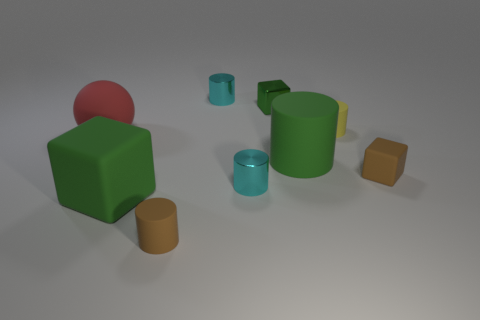Are there any big cylinders made of the same material as the yellow thing?
Make the answer very short. Yes. What is the shape of the yellow rubber thing?
Offer a terse response. Cylinder. The small cyan shiny thing behind the red matte object that is in front of the yellow thing is what shape?
Your answer should be compact. Cylinder. What number of other objects are there of the same shape as the tiny yellow thing?
Give a very brief answer. 4. How big is the rubber block on the right side of the tiny thing in front of the big green cube?
Provide a short and direct response. Small. Are there any big red things?
Your response must be concise. Yes. There is a cube behind the red thing; what number of small cyan shiny objects are left of it?
Offer a very short reply. 2. There is a tiny rubber object behind the large matte sphere; what is its shape?
Offer a terse response. Cylinder. There is a green object to the left of the small rubber thing that is left of the green object behind the red rubber ball; what is it made of?
Offer a very short reply. Rubber. What number of other objects are there of the same size as the yellow matte thing?
Your answer should be very brief. 5. 